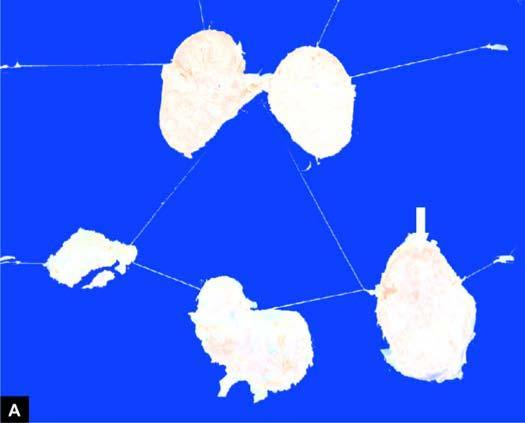what does cut section of matted mass of lymph nodes show?
Answer the question using a single word or phrase. Merging capsules and large areas of caseation necrosis 